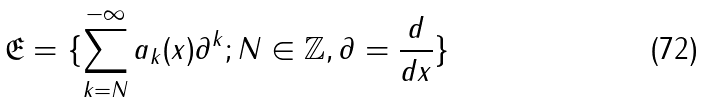<formula> <loc_0><loc_0><loc_500><loc_500>\mathfrak { E } = \{ \sum _ { k = N } ^ { - \infty } a _ { k } ( x ) \partial ^ { k } ; N \in { \mathbb { Z } } , { \partial } = { \frac { d } { d x } } \}</formula> 